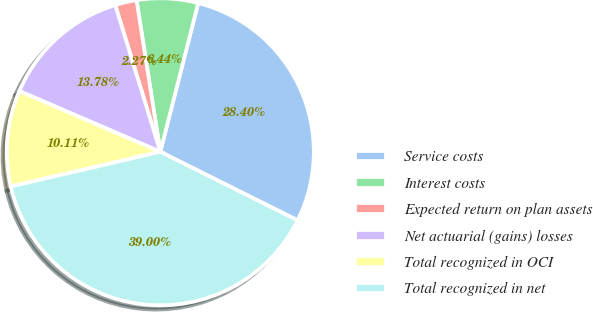Convert chart to OTSL. <chart><loc_0><loc_0><loc_500><loc_500><pie_chart><fcel>Service costs<fcel>Interest costs<fcel>Expected return on plan assets<fcel>Net actuarial (gains) losses<fcel>Total recognized in OCI<fcel>Total recognized in net<nl><fcel>28.4%<fcel>6.44%<fcel>2.27%<fcel>13.78%<fcel>10.11%<fcel>39.0%<nl></chart> 